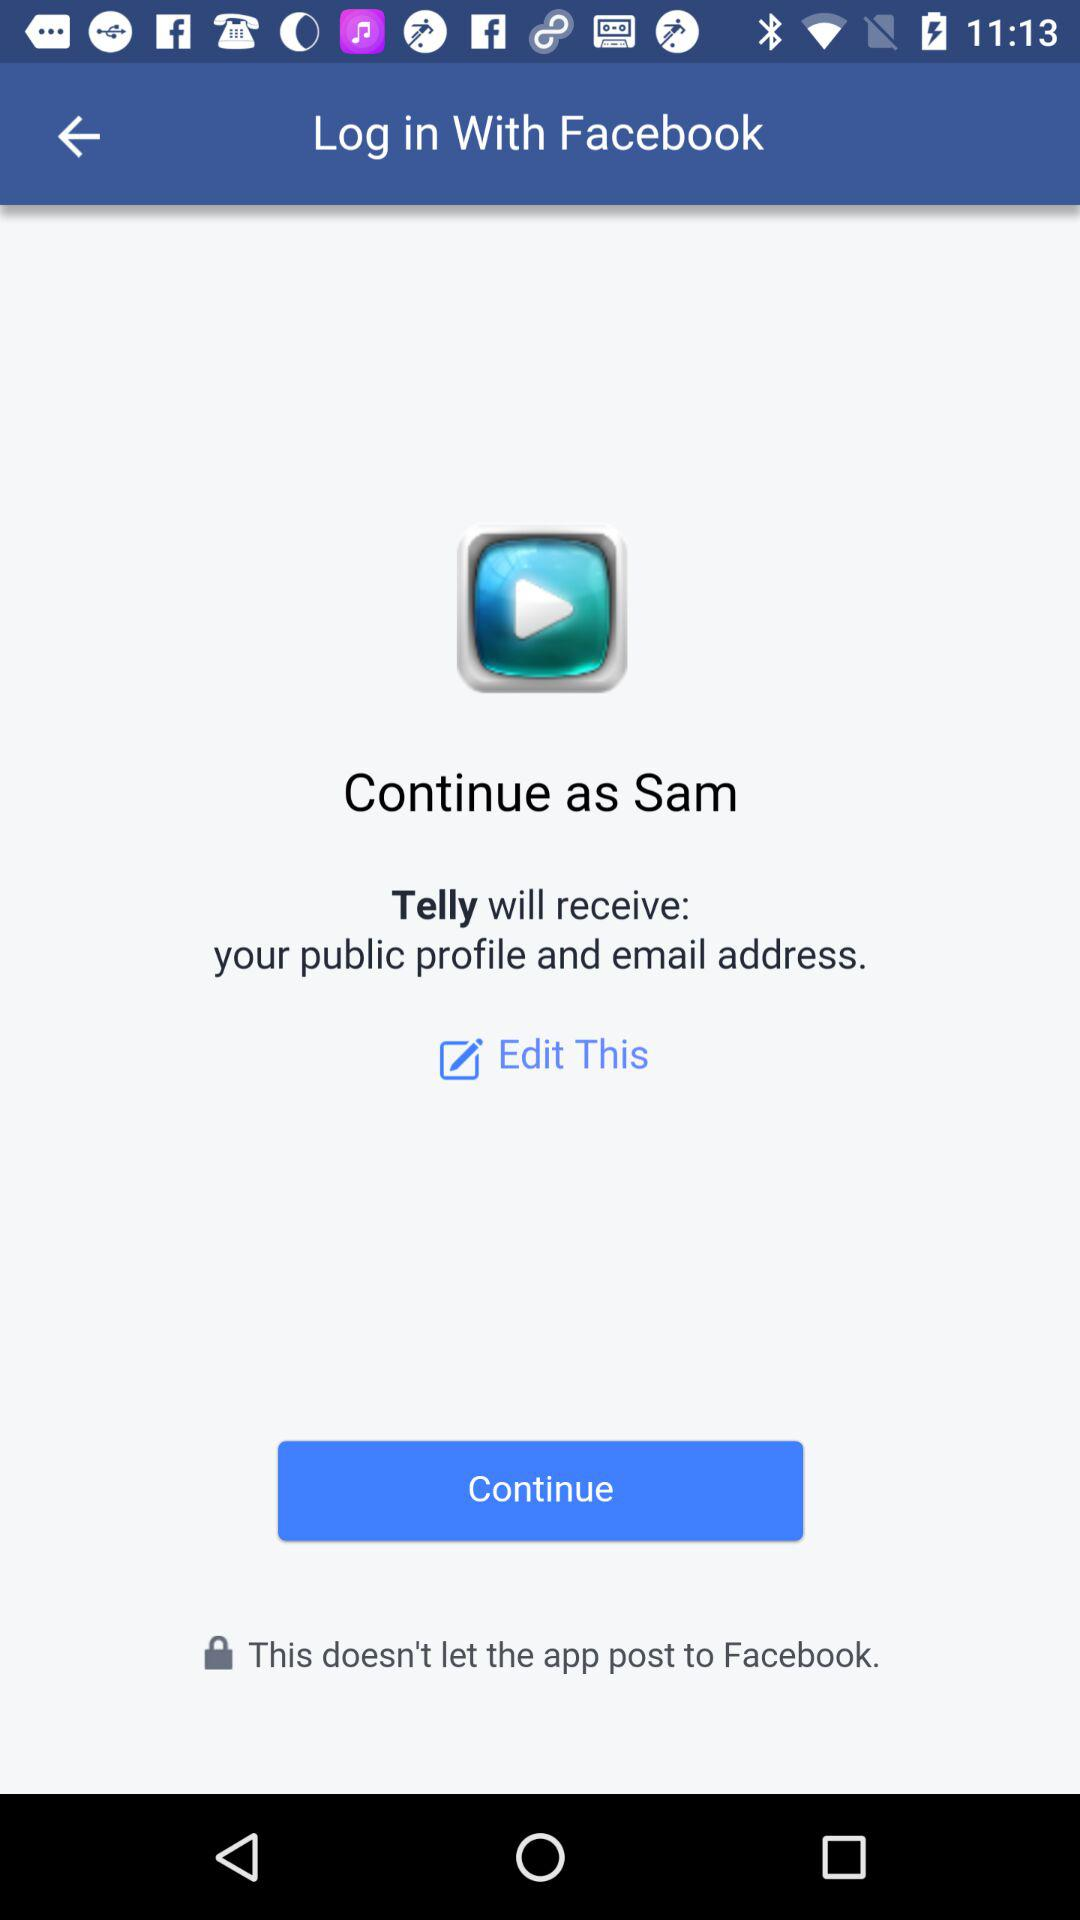Through what application is the person logging in? The person is logging in through the application "Facebook". 